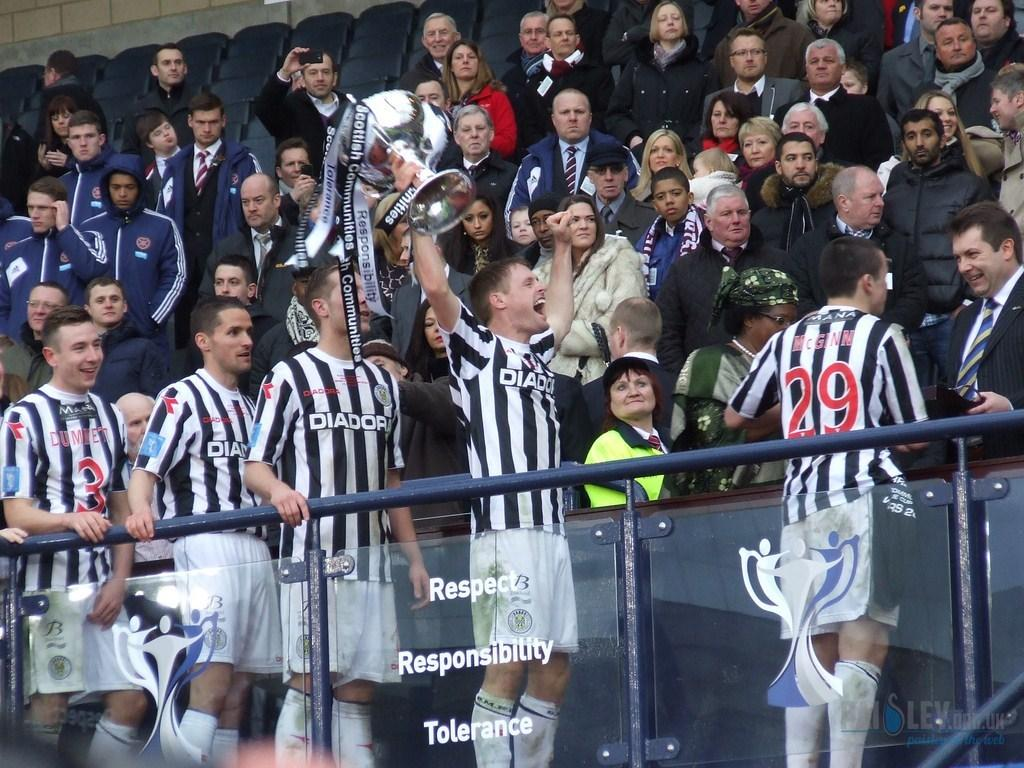<image>
Share a concise interpretation of the image provided. the word respect that is next to some players 